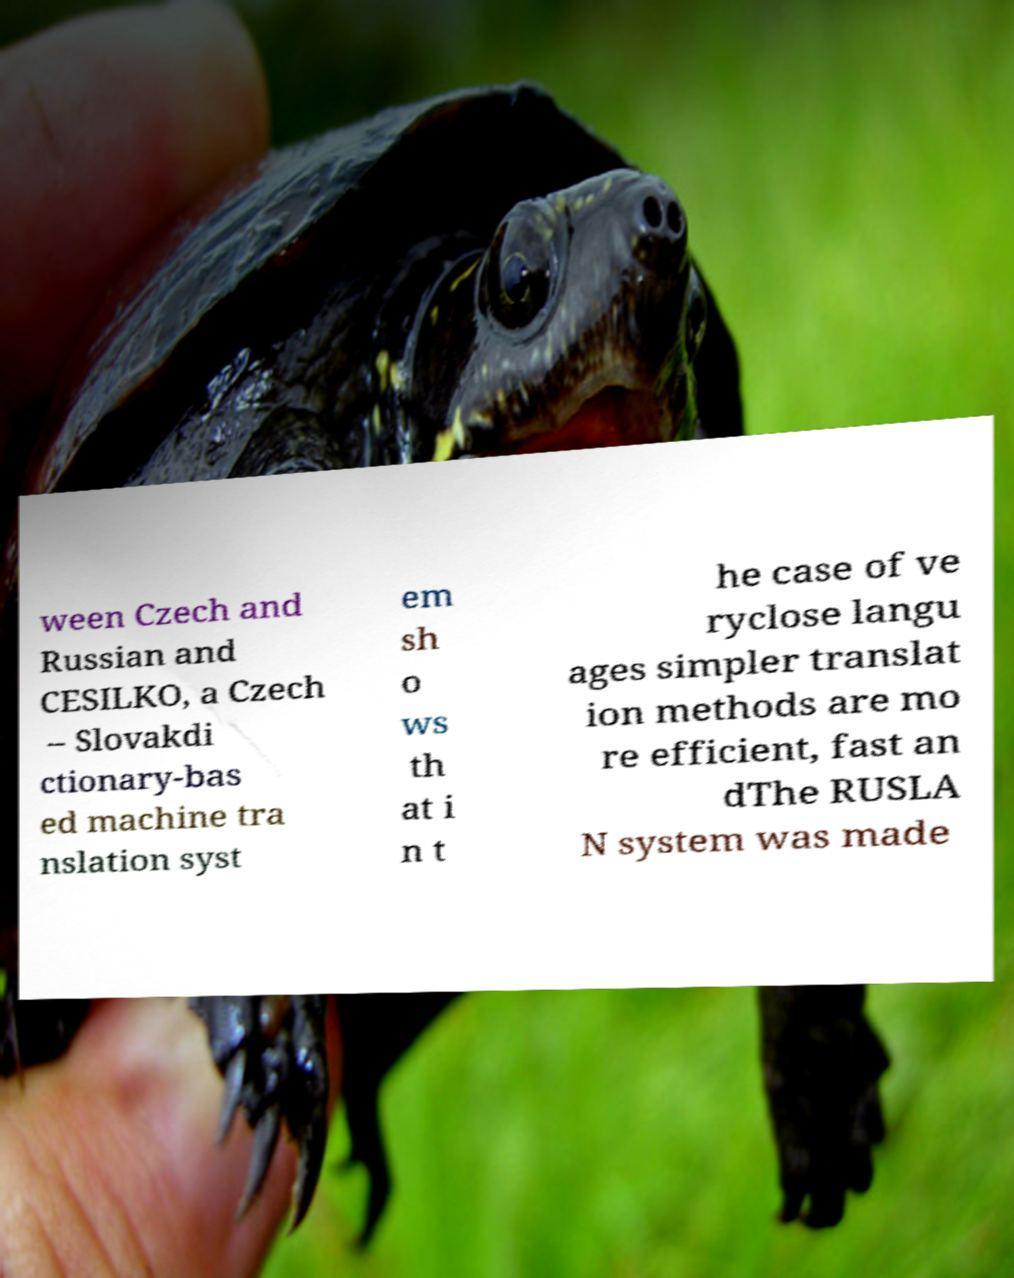For documentation purposes, I need the text within this image transcribed. Could you provide that? ween Czech and Russian and CESILKO, a Czech – Slovakdi ctionary-bas ed machine tra nslation syst em sh o ws th at i n t he case of ve ryclose langu ages simpler translat ion methods are mo re efficient, fast an dThe RUSLA N system was made 